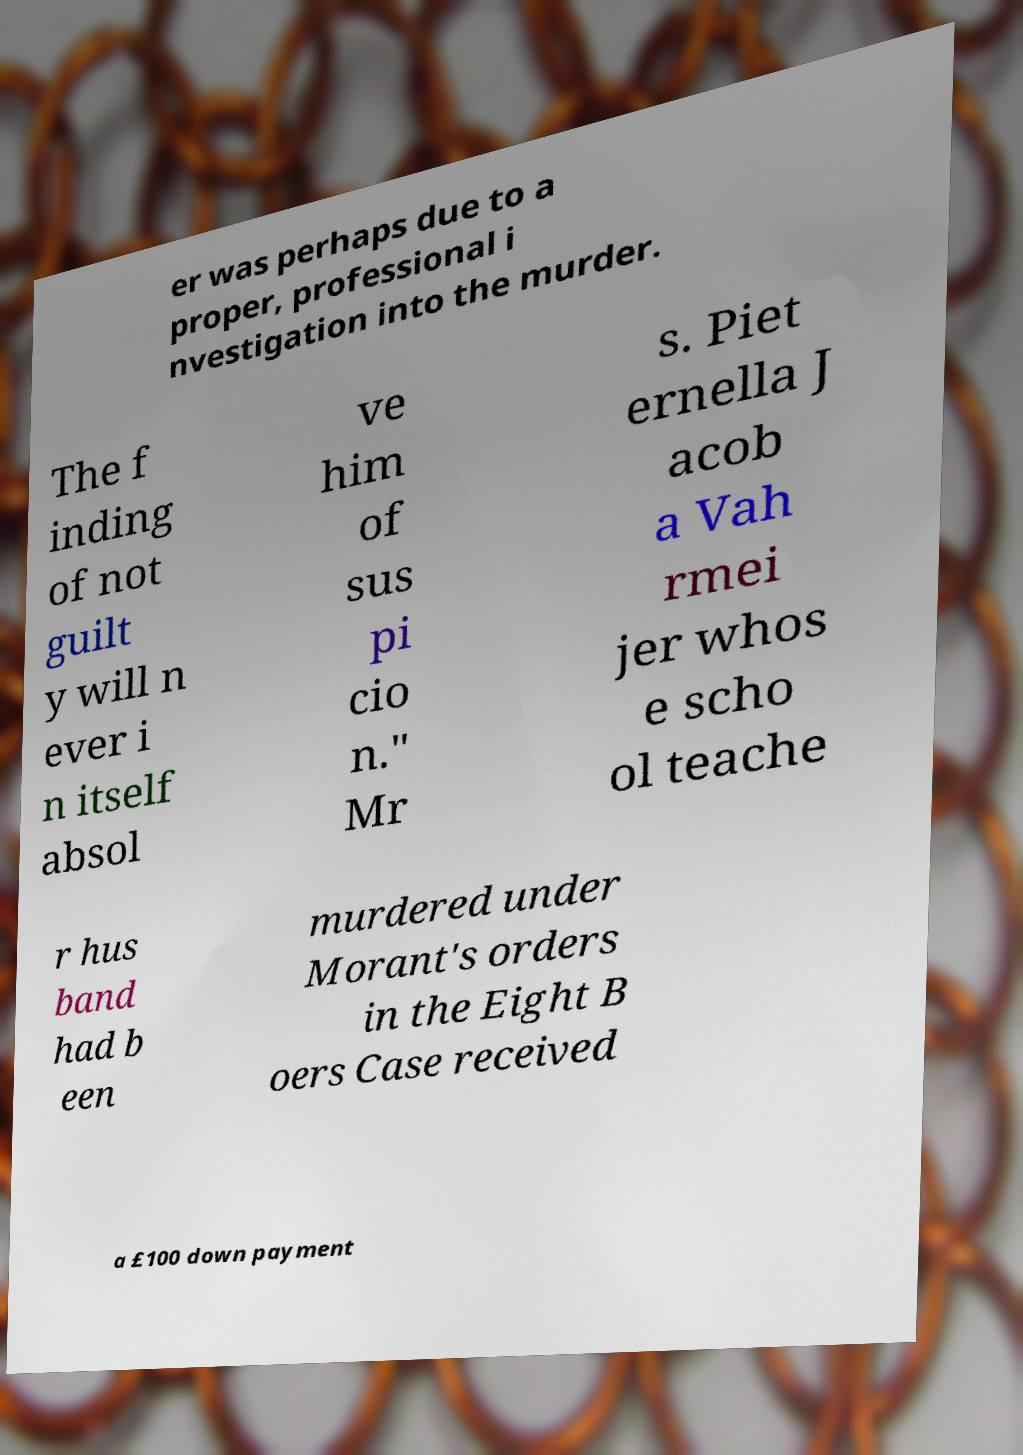Can you accurately transcribe the text from the provided image for me? er was perhaps due to a proper, professional i nvestigation into the murder. The f inding of not guilt y will n ever i n itself absol ve him of sus pi cio n." Mr s. Piet ernella J acob a Vah rmei jer whos e scho ol teache r hus band had b een murdered under Morant's orders in the Eight B oers Case received a £100 down payment 